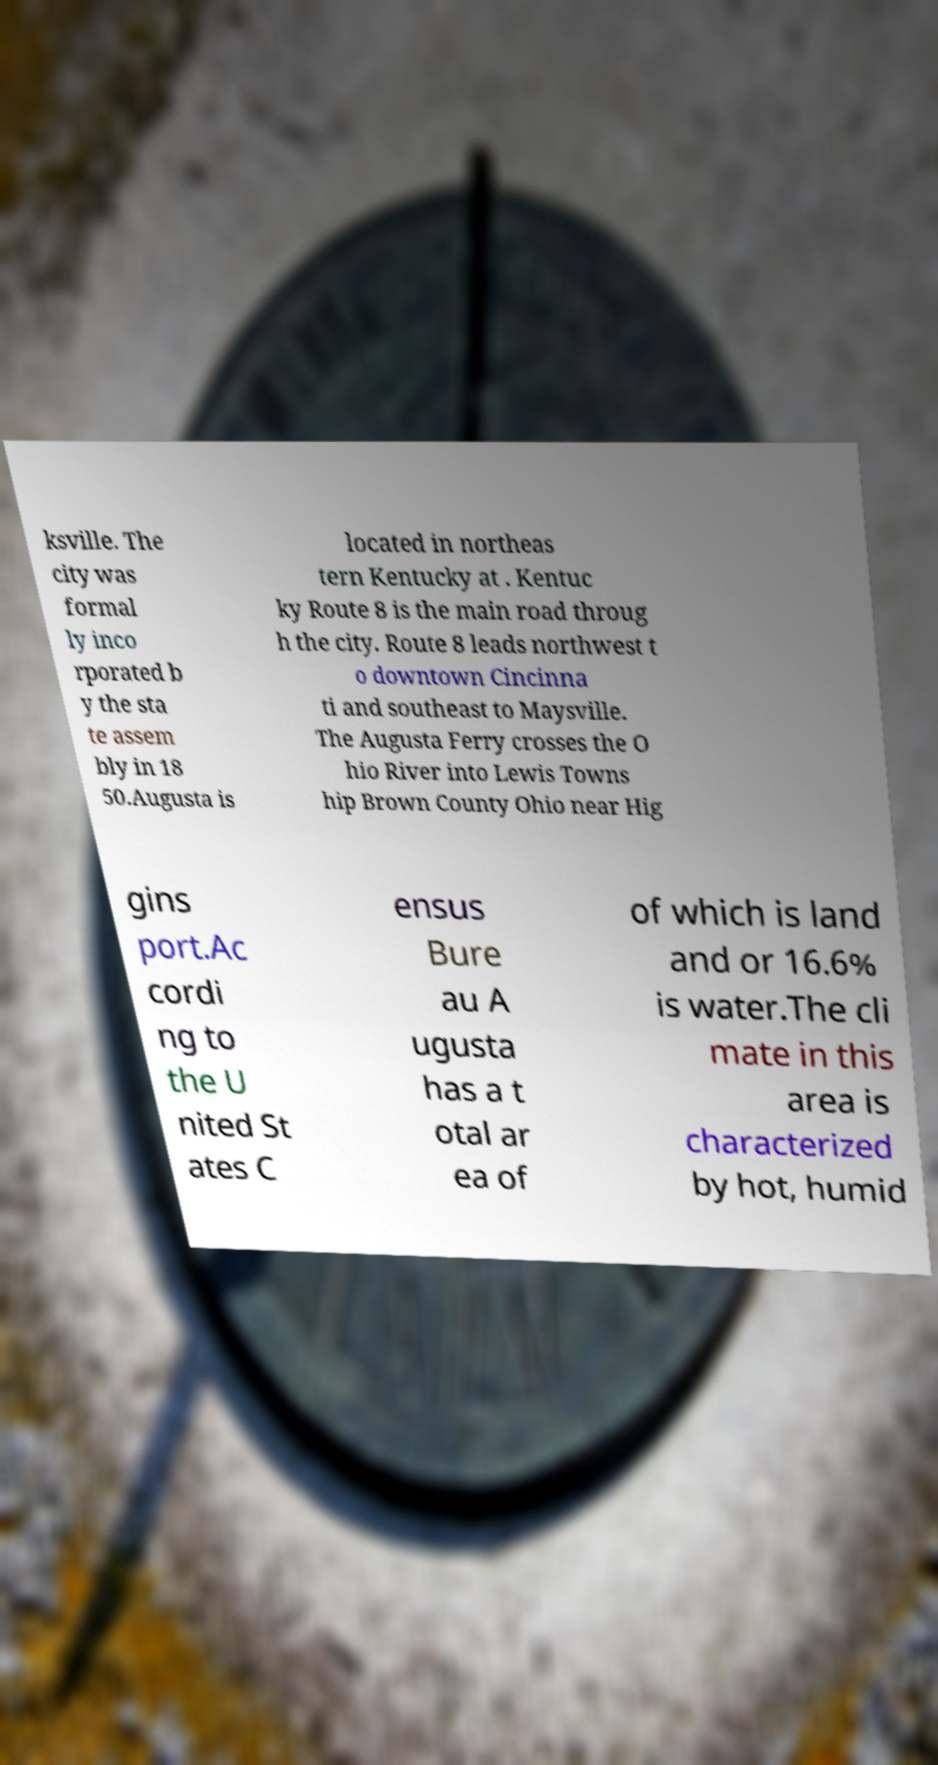For documentation purposes, I need the text within this image transcribed. Could you provide that? ksville. The city was formal ly inco rporated b y the sta te assem bly in 18 50.Augusta is located in northeas tern Kentucky at . Kentuc ky Route 8 is the main road throug h the city. Route 8 leads northwest t o downtown Cincinna ti and southeast to Maysville. The Augusta Ferry crosses the O hio River into Lewis Towns hip Brown County Ohio near Hig gins port.Ac cordi ng to the U nited St ates C ensus Bure au A ugusta has a t otal ar ea of of which is land and or 16.6% is water.The cli mate in this area is characterized by hot, humid 